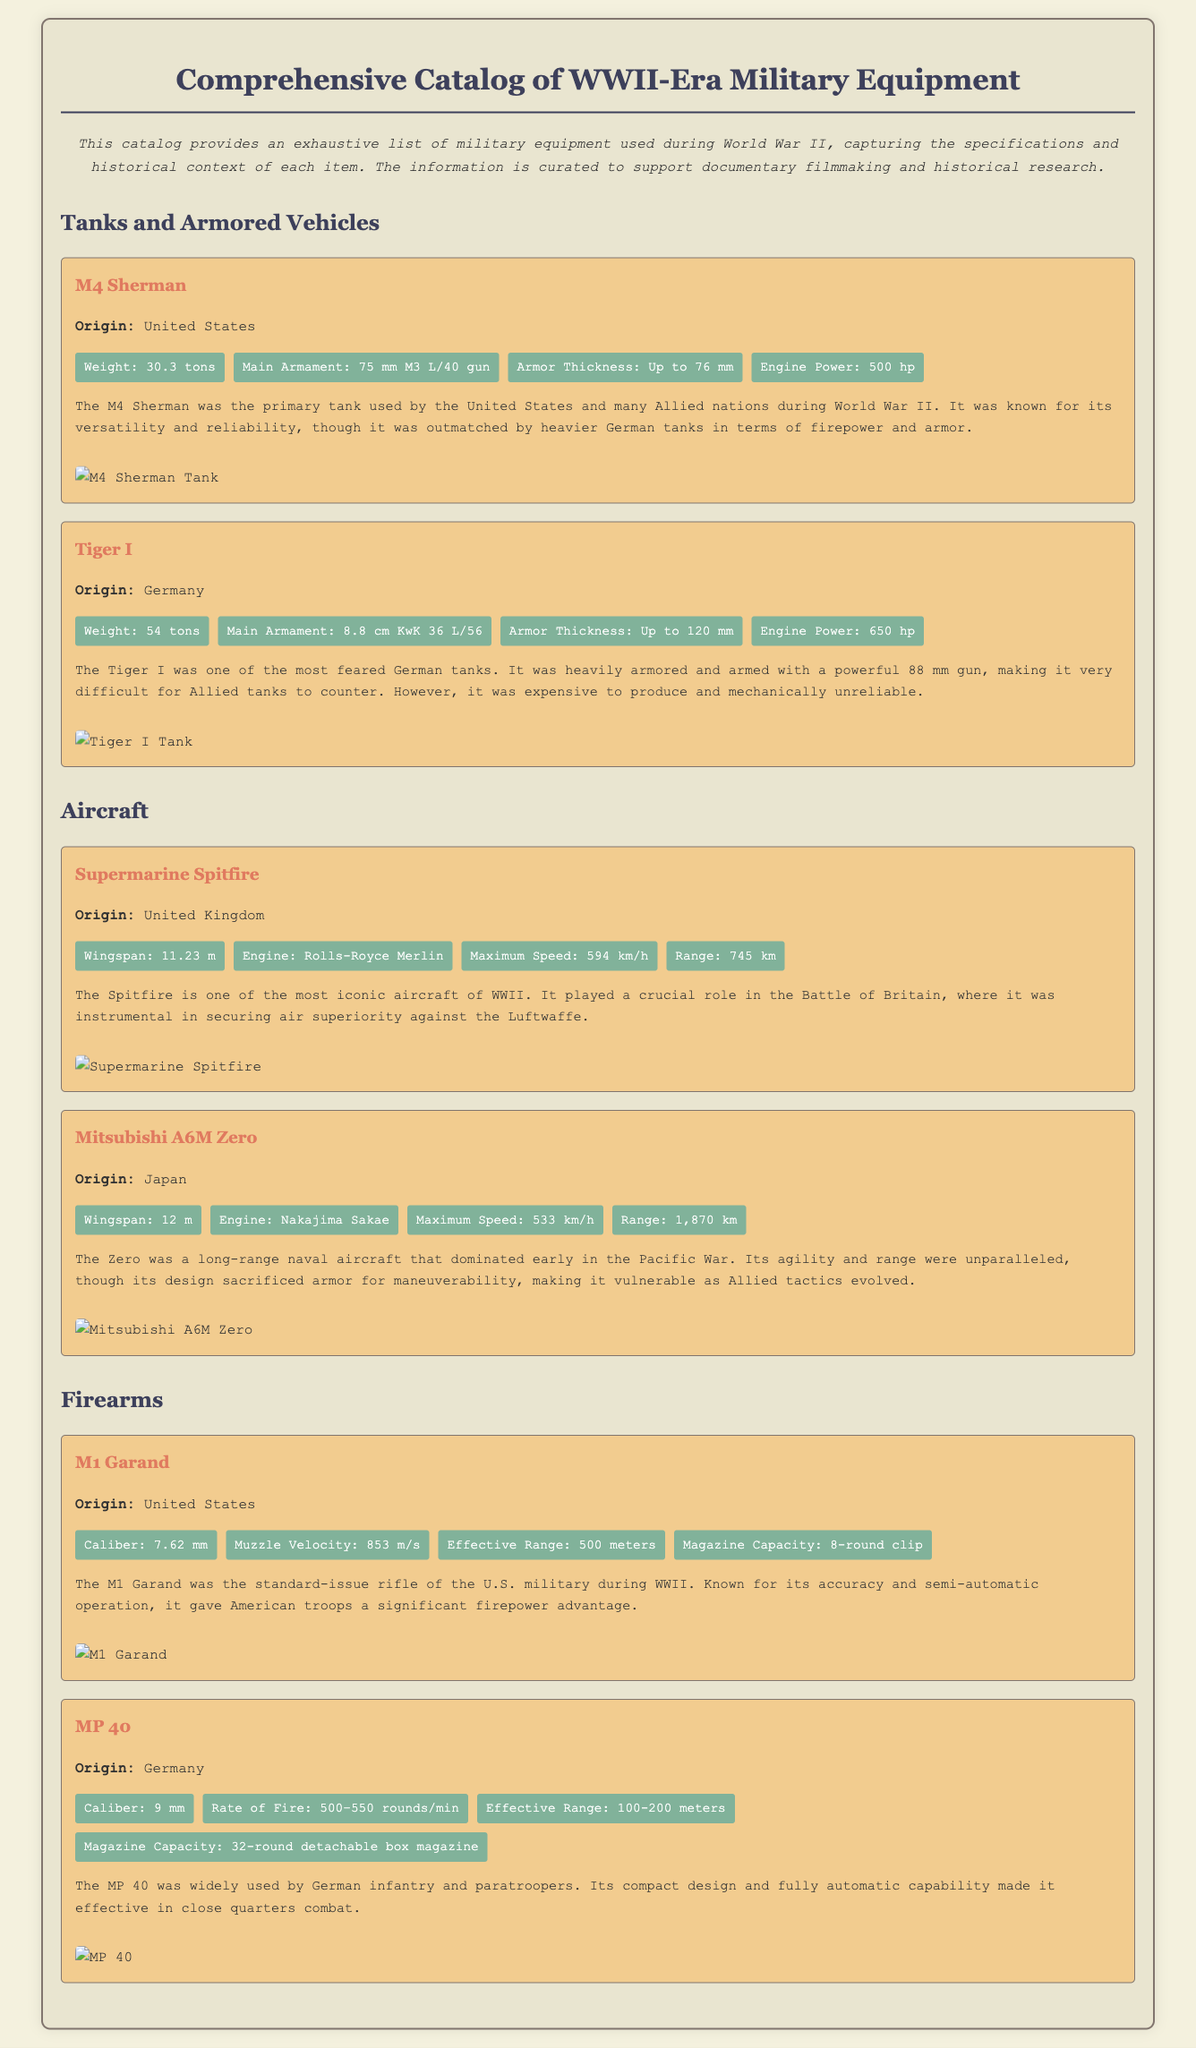what is the weight of the M4 Sherman? The weight of the M4 Sherman is listed as 30.3 tons in the specifications.
Answer: 30.3 tons what is the main armament of the Tiger I? The main armament of the Tiger I is an 8.8 cm KwK 36 L/56 gun according to the document.
Answer: 8.8 cm KwK 36 L/56 which aircraft is associated with the Rolls-Royce Merlin engine? The Supermarine Spitfire is identified with the Rolls-Royce Merlin engine in the document.
Answer: Supermarine Spitfire what is the effective range of the M1 Garand? The effective range of the M1 Garand is specified as 500 meters in the document.
Answer: 500 meters which nation produced the MP 40? The document states that the MP 40 was produced by Germany.
Answer: Germany how does the armor thickness of the Tiger I compare to that of the M4 Sherman? The Tiger I has an armor thickness of up to 120 mm while the M4 Sherman is up to 76 mm, indicating the Tiger I is better armored.
Answer: Tiger I is better armored what is the maximum speed of the Mitsubishi A6M Zero? The document provides that the maximum speed of the Mitsubishi A6M Zero is 533 km/h.
Answer: 533 km/h what type of document is this? This document is a comprehensive catalog of WWII-era military equipment as stated in the introduction.
Answer: comprehensive catalog how are the items organized in the catalog? The items in the catalog are organized by categories, including Tanks and Armored Vehicles, Aircraft, and Firearms.
Answer: by categories 